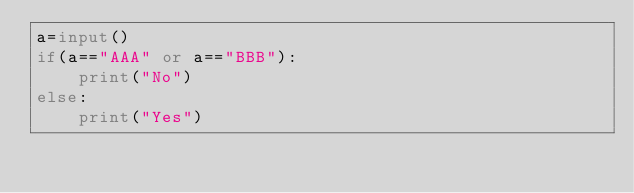<code> <loc_0><loc_0><loc_500><loc_500><_Python_>a=input()
if(a=="AAA" or a=="BBB"):
    print("No")
else:
    print("Yes")</code> 